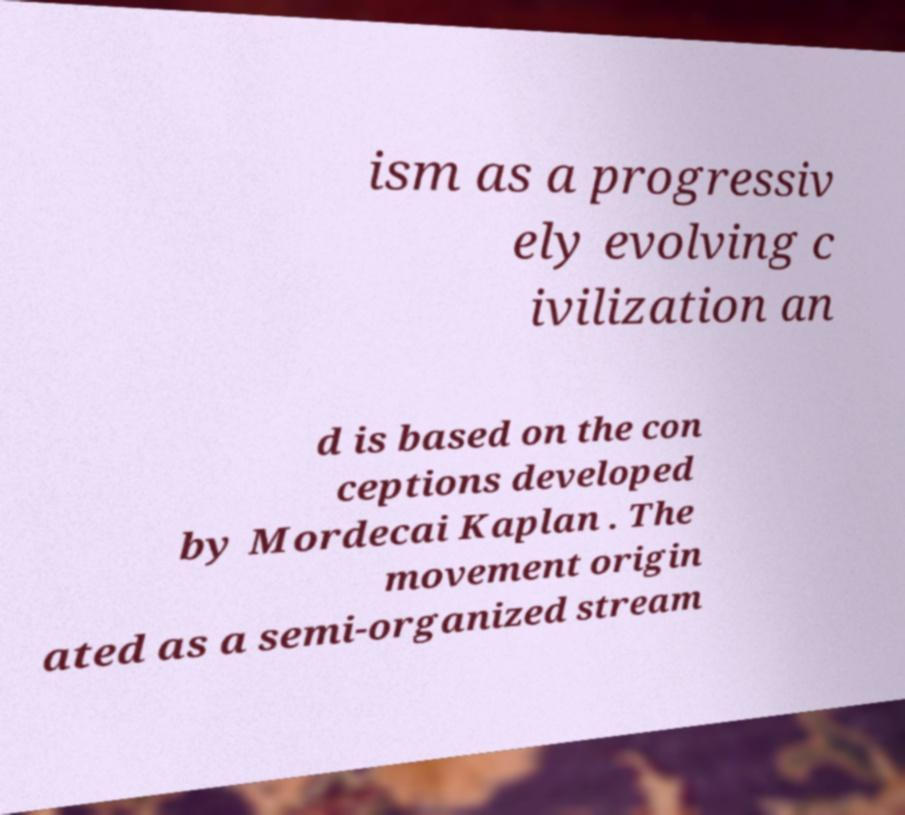For documentation purposes, I need the text within this image transcribed. Could you provide that? ism as a progressiv ely evolving c ivilization an d is based on the con ceptions developed by Mordecai Kaplan . The movement origin ated as a semi-organized stream 